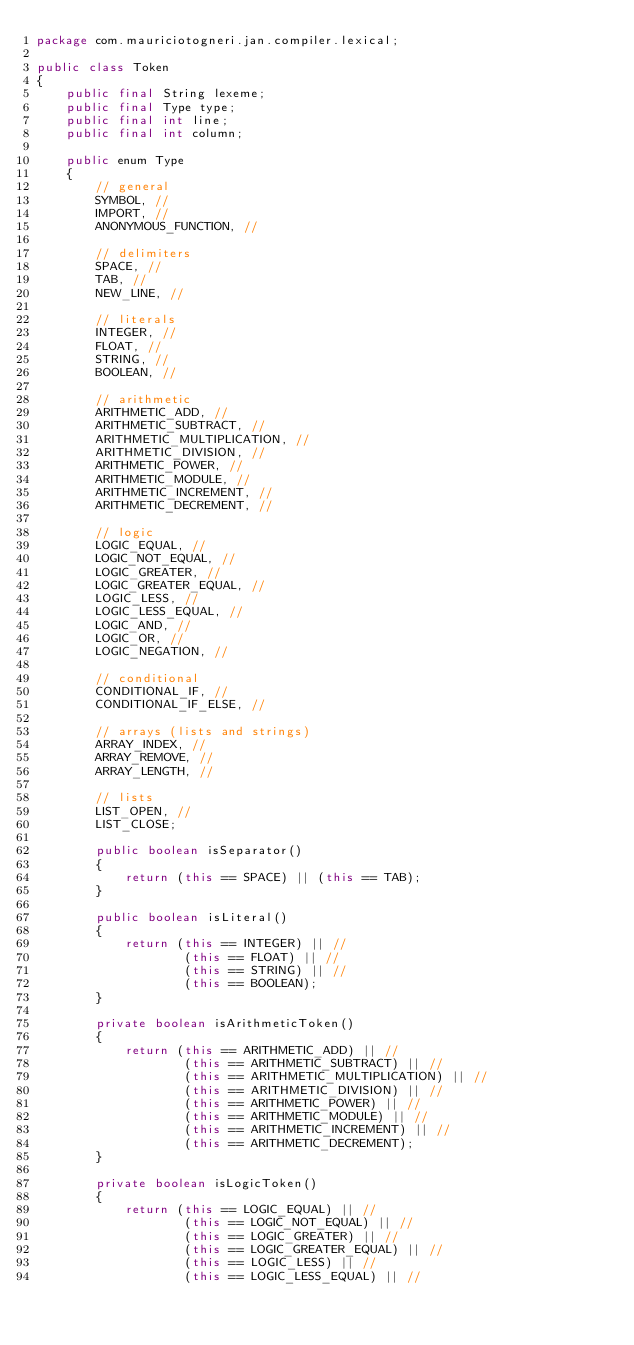Convert code to text. <code><loc_0><loc_0><loc_500><loc_500><_Java_>package com.mauriciotogneri.jan.compiler.lexical;

public class Token
{
    public final String lexeme;
    public final Type type;
    public final int line;
    public final int column;

    public enum Type
    {
        // general
        SYMBOL, //
        IMPORT, //
        ANONYMOUS_FUNCTION, //

        // delimiters
        SPACE, //
        TAB, //
        NEW_LINE, //

        // literals
        INTEGER, //
        FLOAT, //
        STRING, //
        BOOLEAN, //

        // arithmetic
        ARITHMETIC_ADD, //
        ARITHMETIC_SUBTRACT, //
        ARITHMETIC_MULTIPLICATION, //
        ARITHMETIC_DIVISION, //
        ARITHMETIC_POWER, //
        ARITHMETIC_MODULE, //
        ARITHMETIC_INCREMENT, //
        ARITHMETIC_DECREMENT, //

        // logic
        LOGIC_EQUAL, //
        LOGIC_NOT_EQUAL, //
        LOGIC_GREATER, //
        LOGIC_GREATER_EQUAL, //
        LOGIC_LESS, //
        LOGIC_LESS_EQUAL, //
        LOGIC_AND, //
        LOGIC_OR, //
        LOGIC_NEGATION, //

        // conditional
        CONDITIONAL_IF, //
        CONDITIONAL_IF_ELSE, //

        // arrays (lists and strings)
        ARRAY_INDEX, //
        ARRAY_REMOVE, //
        ARRAY_LENGTH, //

        // lists
        LIST_OPEN, //
        LIST_CLOSE;

        public boolean isSeparator()
        {
            return (this == SPACE) || (this == TAB);
        }

        public boolean isLiteral()
        {
            return (this == INTEGER) || //
                    (this == FLOAT) || //
                    (this == STRING) || //
                    (this == BOOLEAN);
        }

        private boolean isArithmeticToken()
        {
            return (this == ARITHMETIC_ADD) || //
                    (this == ARITHMETIC_SUBTRACT) || //
                    (this == ARITHMETIC_MULTIPLICATION) || //
                    (this == ARITHMETIC_DIVISION) || //
                    (this == ARITHMETIC_POWER) || //
                    (this == ARITHMETIC_MODULE) || //
                    (this == ARITHMETIC_INCREMENT) || //
                    (this == ARITHMETIC_DECREMENT);
        }

        private boolean isLogicToken()
        {
            return (this == LOGIC_EQUAL) || //
                    (this == LOGIC_NOT_EQUAL) || //
                    (this == LOGIC_GREATER) || //
                    (this == LOGIC_GREATER_EQUAL) || //
                    (this == LOGIC_LESS) || //
                    (this == LOGIC_LESS_EQUAL) || //</code> 